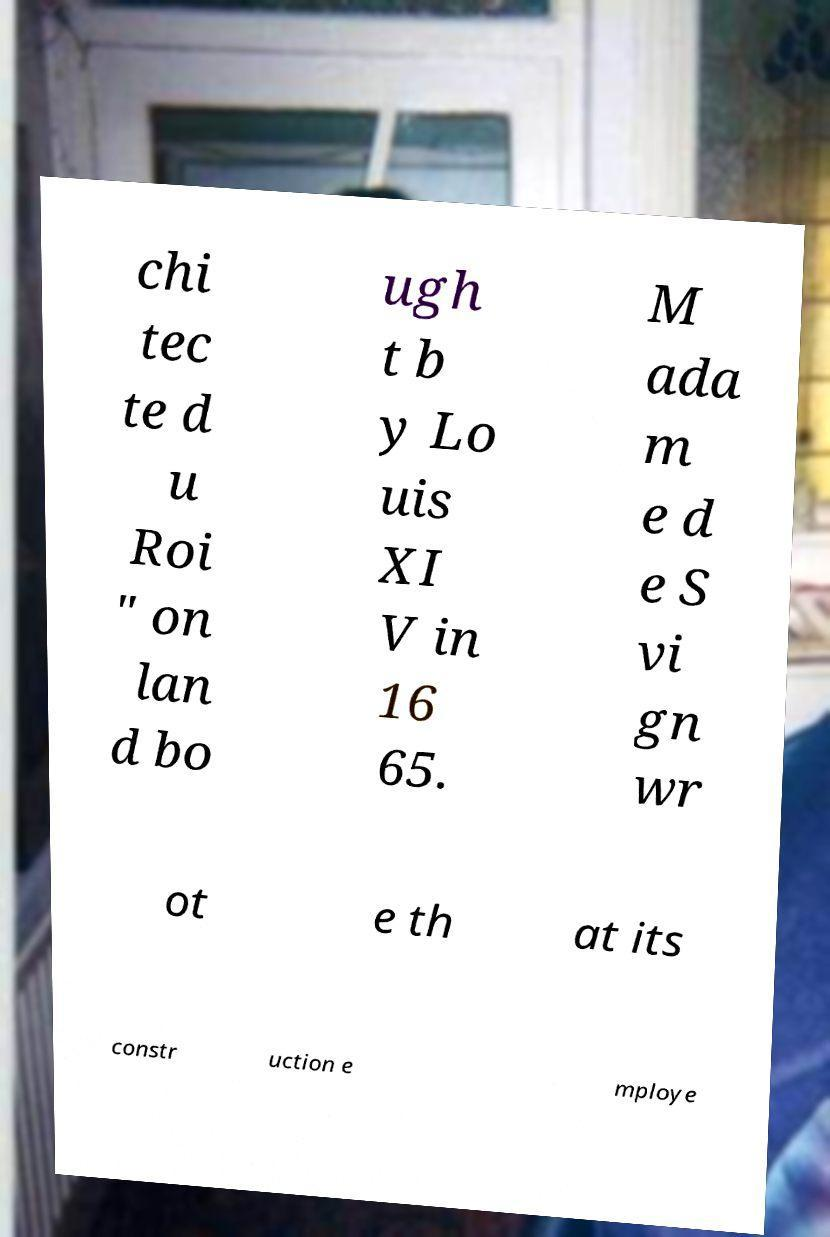Please read and relay the text visible in this image. What does it say? chi tec te d u Roi " on lan d bo ugh t b y Lo uis XI V in 16 65. M ada m e d e S vi gn wr ot e th at its constr uction e mploye 